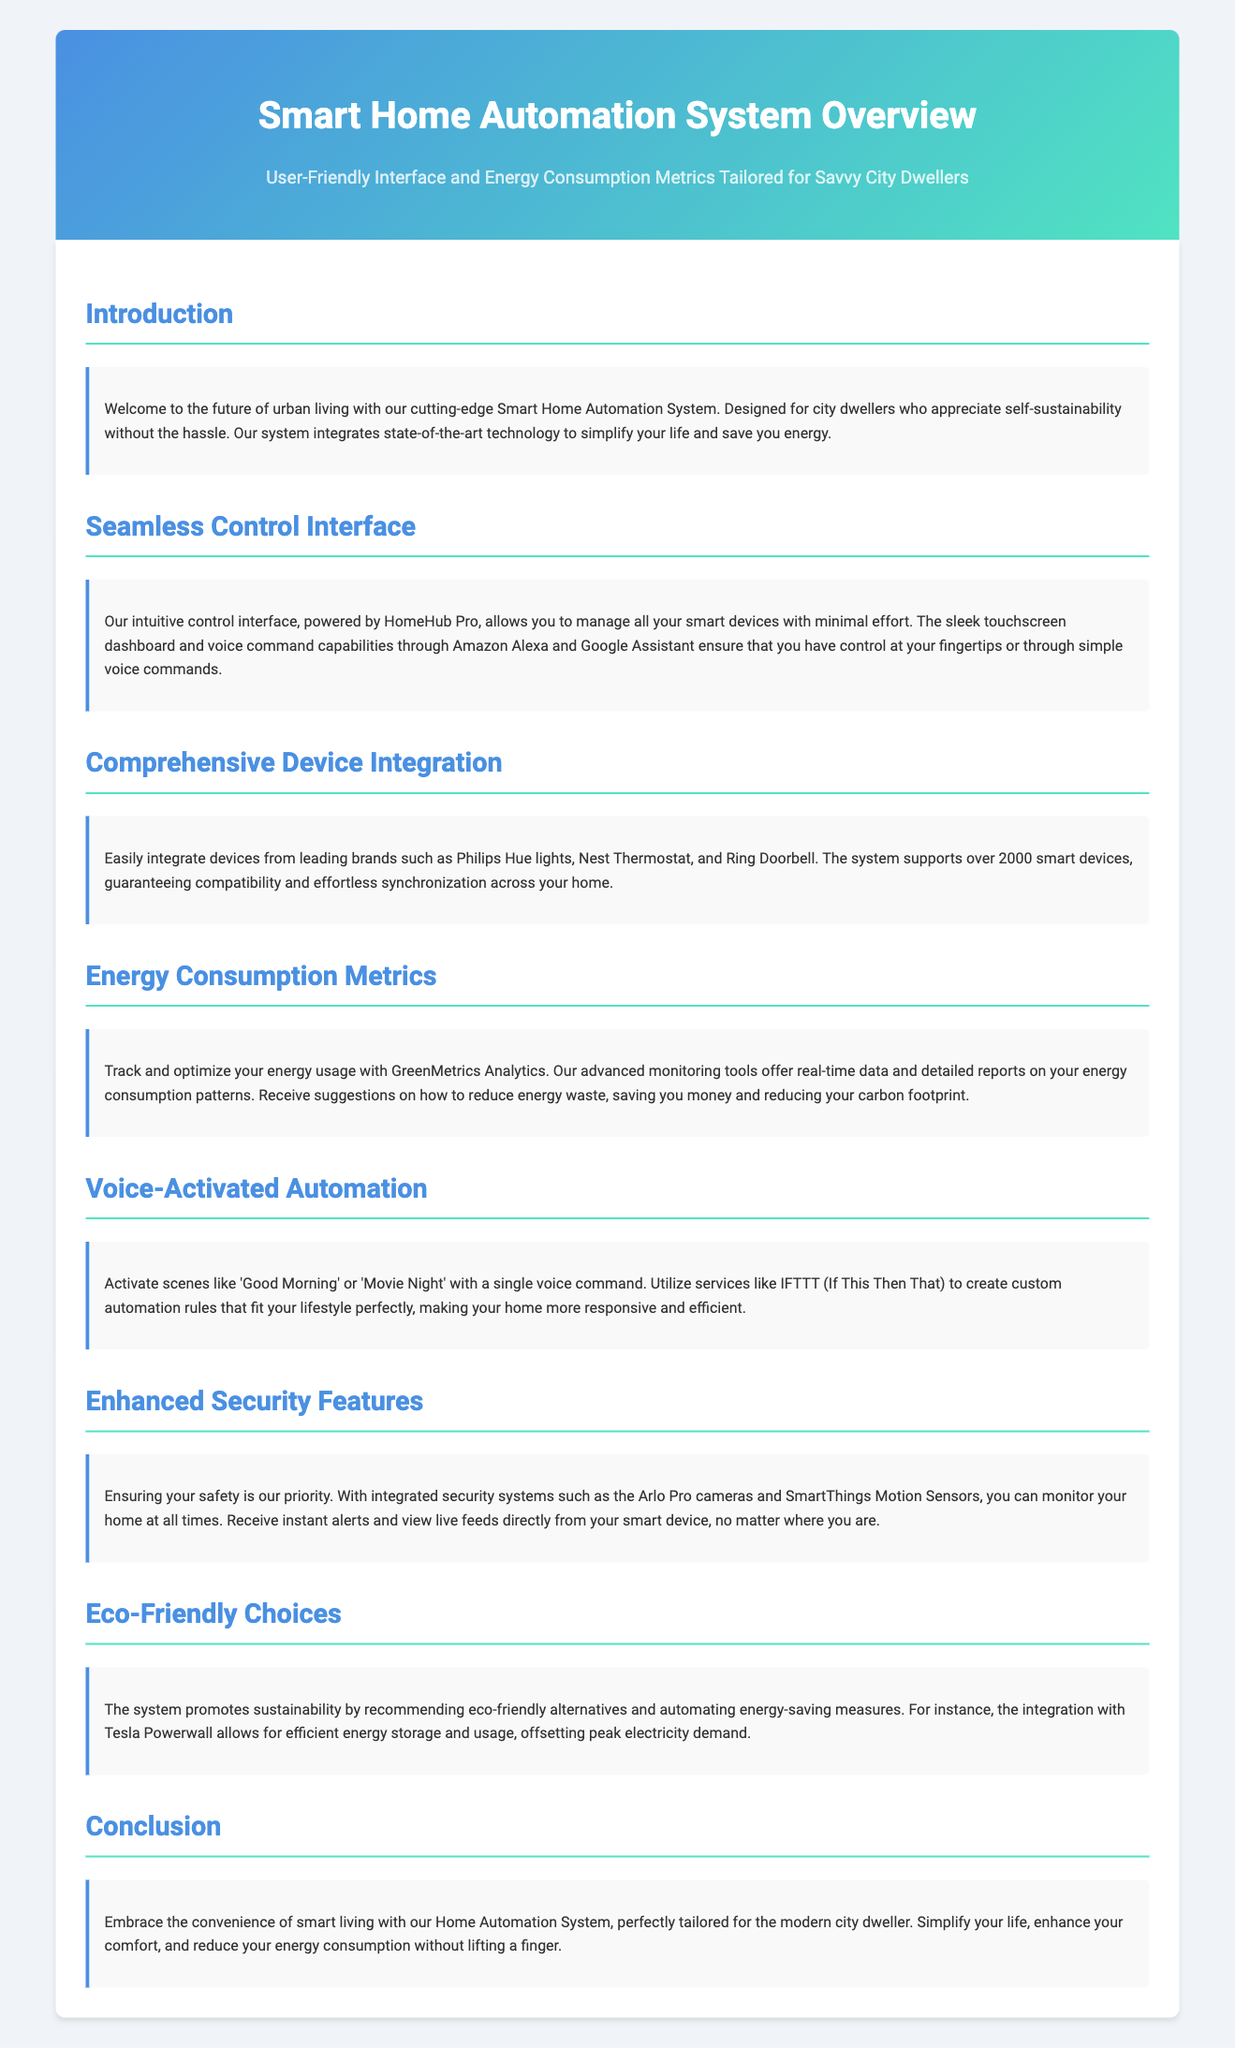What is the title of the document? The title is prominently displayed in the header section of the document.
Answer: Smart Home Automation System Overview What is the main focus of the Smart Home Automation System? The document states the system is designed for urban living and self-sustainability without hassle.
Answer: Self-sustainability How many smart devices does the system support? The text explicitly mentions the number of compatible smart devices in the document.
Answer: Over 2000 What technology powers the control interface? The document identifies the specific interface technology used in managing smart devices.
Answer: HomeHub Pro What kind of analytics does the system provide? The document lists the type of metrics used to track energy consumption.
Answer: GreenMetrics Analytics What is an example of a voice-activated scene? The document provides specific examples of user commands for automating scenes.
Answer: Good Morning Name one security feature mentioned in the document. The document highlights certain security systems integrated into the smart home system.
Answer: Arlo Pro cameras What eco-friendly integration does the system include? The text provides an example of a feature that promotes sustainability through energy storage.
Answer: Tesla Powerwall What is the primary benefit mentioned in the conclusion? The conclusion summarizes the overall advantage of using the Smart Home Automation System.
Answer: Simplify your life 